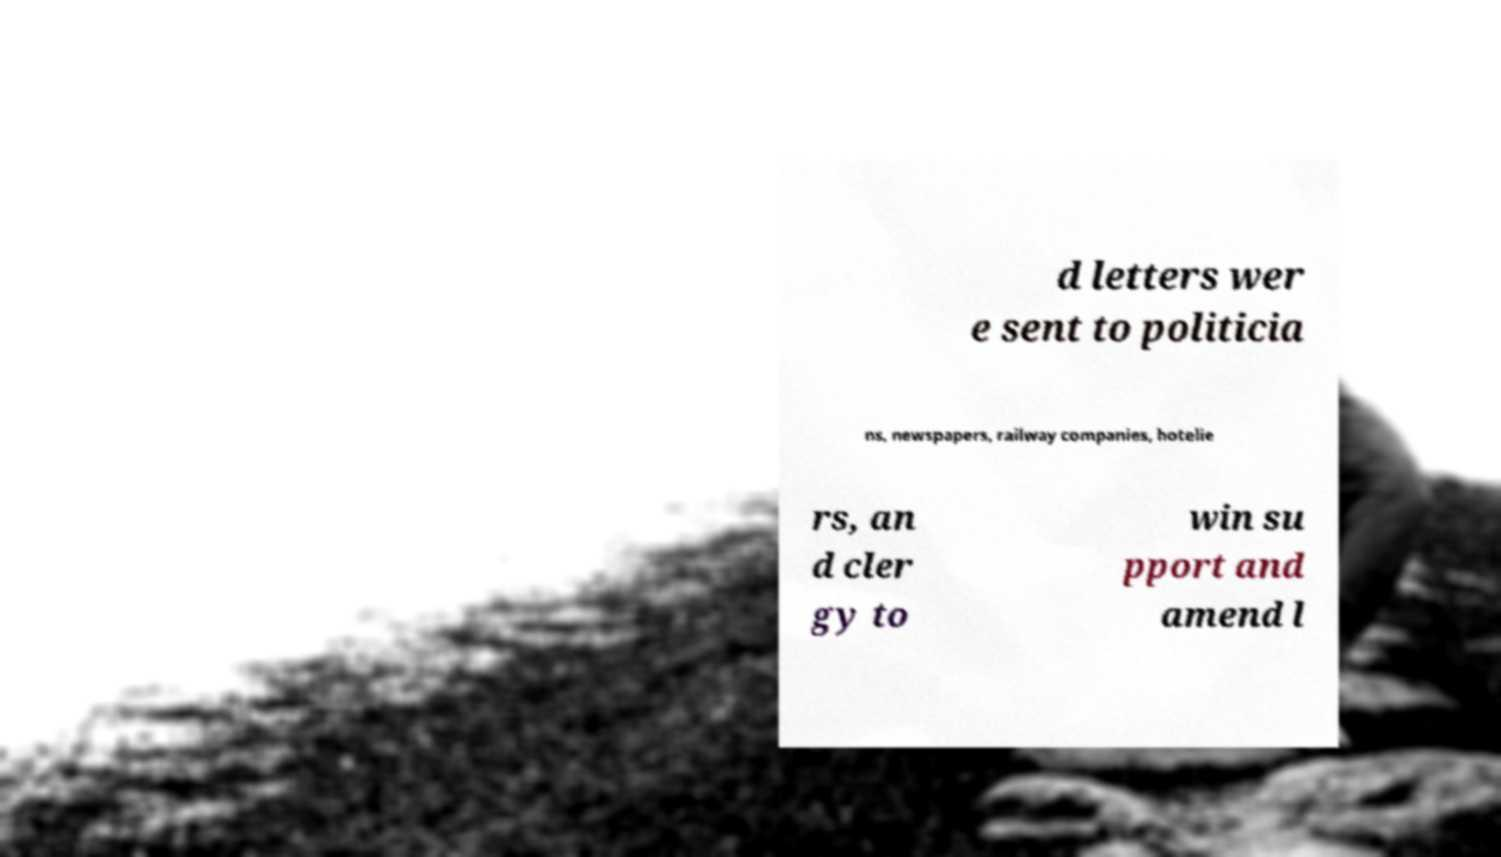What messages or text are displayed in this image? I need them in a readable, typed format. d letters wer e sent to politicia ns, newspapers, railway companies, hotelie rs, an d cler gy to win su pport and amend l 